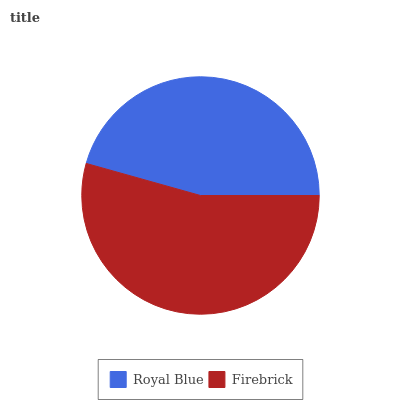Is Royal Blue the minimum?
Answer yes or no. Yes. Is Firebrick the maximum?
Answer yes or no. Yes. Is Firebrick the minimum?
Answer yes or no. No. Is Firebrick greater than Royal Blue?
Answer yes or no. Yes. Is Royal Blue less than Firebrick?
Answer yes or no. Yes. Is Royal Blue greater than Firebrick?
Answer yes or no. No. Is Firebrick less than Royal Blue?
Answer yes or no. No. Is Firebrick the high median?
Answer yes or no. Yes. Is Royal Blue the low median?
Answer yes or no. Yes. Is Royal Blue the high median?
Answer yes or no. No. Is Firebrick the low median?
Answer yes or no. No. 